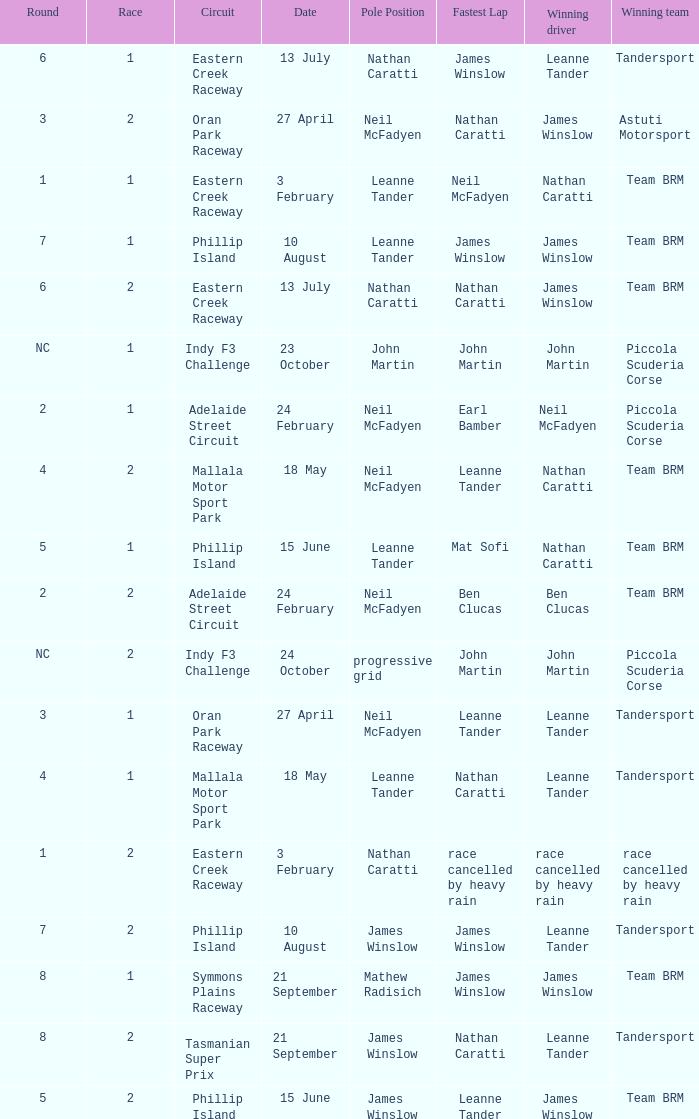Could you help me parse every detail presented in this table? {'header': ['Round', 'Race', 'Circuit', 'Date', 'Pole Position', 'Fastest Lap', 'Winning driver', 'Winning team'], 'rows': [['6', '1', 'Eastern Creek Raceway', '13 July', 'Nathan Caratti', 'James Winslow', 'Leanne Tander', 'Tandersport'], ['3', '2', 'Oran Park Raceway', '27 April', 'Neil McFadyen', 'Nathan Caratti', 'James Winslow', 'Astuti Motorsport'], ['1', '1', 'Eastern Creek Raceway', '3 February', 'Leanne Tander', 'Neil McFadyen', 'Nathan Caratti', 'Team BRM'], ['7', '1', 'Phillip Island', '10 August', 'Leanne Tander', 'James Winslow', 'James Winslow', 'Team BRM'], ['6', '2', 'Eastern Creek Raceway', '13 July', 'Nathan Caratti', 'Nathan Caratti', 'James Winslow', 'Team BRM'], ['NC', '1', 'Indy F3 Challenge', '23 October', 'John Martin', 'John Martin', 'John Martin', 'Piccola Scuderia Corse'], ['2', '1', 'Adelaide Street Circuit', '24 February', 'Neil McFadyen', 'Earl Bamber', 'Neil McFadyen', 'Piccola Scuderia Corse'], ['4', '2', 'Mallala Motor Sport Park', '18 May', 'Neil McFadyen', 'Leanne Tander', 'Nathan Caratti', 'Team BRM'], ['5', '1', 'Phillip Island', '15 June', 'Leanne Tander', 'Mat Sofi', 'Nathan Caratti', 'Team BRM'], ['2', '2', 'Adelaide Street Circuit', '24 February', 'Neil McFadyen', 'Ben Clucas', 'Ben Clucas', 'Team BRM'], ['NC', '2', 'Indy F3 Challenge', '24 October', 'progressive grid', 'John Martin', 'John Martin', 'Piccola Scuderia Corse'], ['3', '1', 'Oran Park Raceway', '27 April', 'Neil McFadyen', 'Leanne Tander', 'Leanne Tander', 'Tandersport'], ['4', '1', 'Mallala Motor Sport Park', '18 May', 'Leanne Tander', 'Nathan Caratti', 'Leanne Tander', 'Tandersport'], ['1', '2', 'Eastern Creek Raceway', '3 February', 'Nathan Caratti', 'race cancelled by heavy rain', 'race cancelled by heavy rain', 'race cancelled by heavy rain'], ['7', '2', 'Phillip Island', '10 August', 'James Winslow', 'James Winslow', 'Leanne Tander', 'Tandersport'], ['8', '1', 'Symmons Plains Raceway', '21 September', 'Mathew Radisich', 'James Winslow', 'James Winslow', 'Team BRM'], ['8', '2', 'Tasmanian Super Prix', '21 September', 'James Winslow', 'Nathan Caratti', 'Leanne Tander', 'Tandersport'], ['5', '2', 'Phillip Island', '15 June', 'James Winslow', 'Leanne Tander', 'James Winslow', 'Team BRM']]} In the phillip island circuit races, what is the highest race number where james winslow achieved both a win and a pole position? 2.0. 